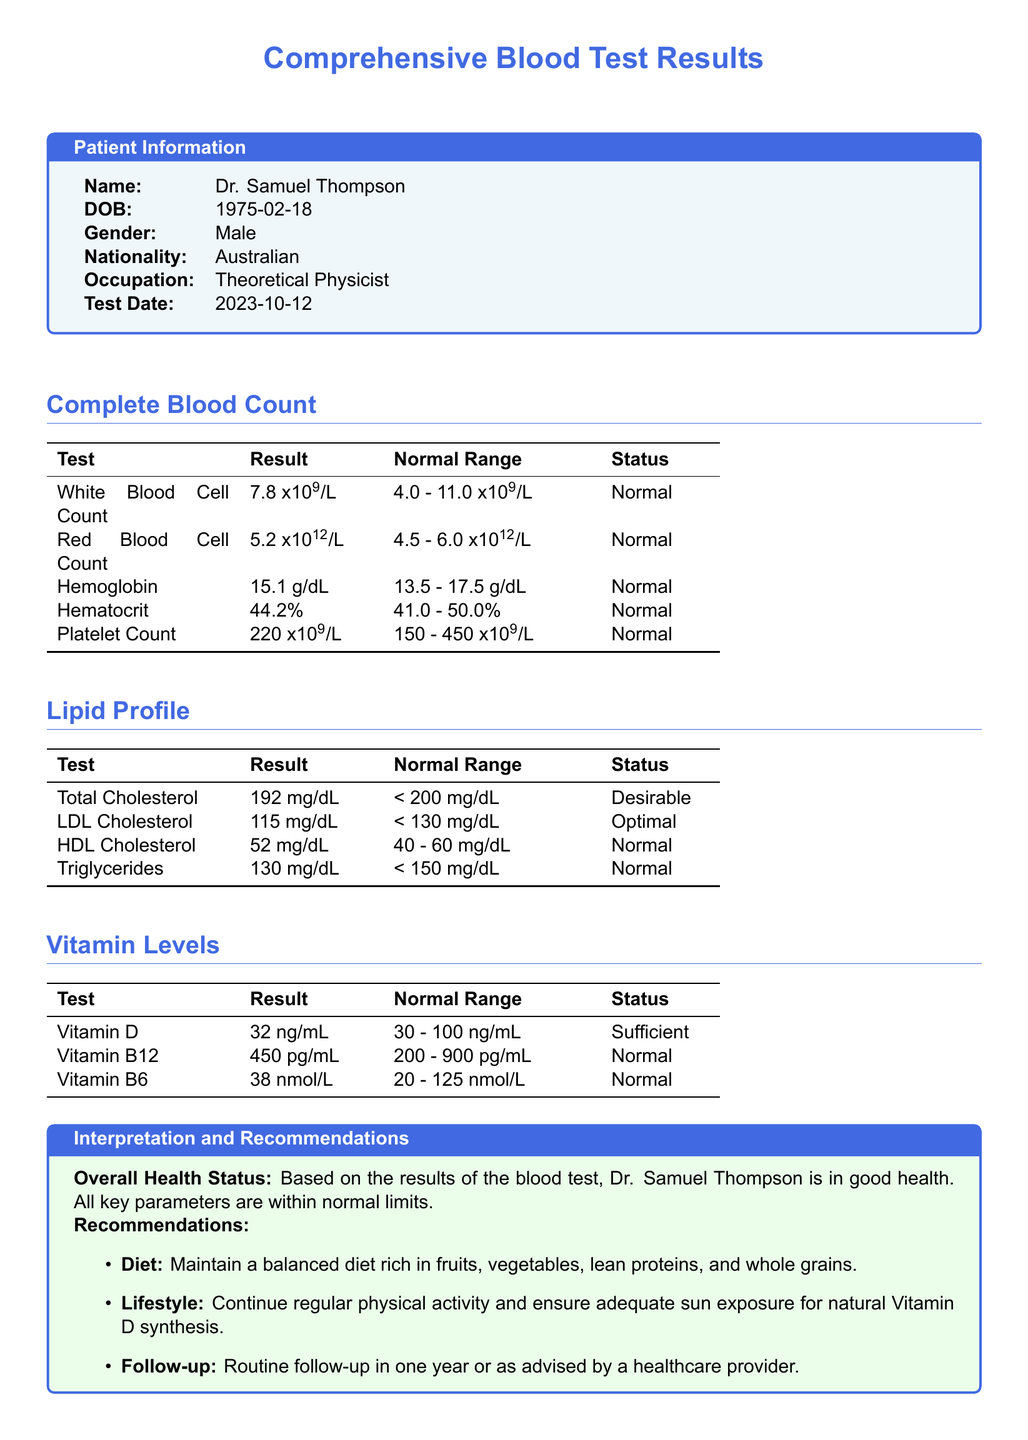What is the patient's name? The patient's name is provided in the Patient Information section of the document.
Answer: Dr. Samuel Thompson What is the date of the blood test? The test date is listed under Patient Information, indicating when the blood test was conducted.
Answer: 2023-10-12 What is the result of the White Blood Cell Count? This result is found in the Complete Blood Count section of the document.
Answer: 7.8 x10^9/L What is the normal range for HDL Cholesterol? The normal range for HDL Cholesterol is specified in the Lipid Profile section.
Answer: 40 - 60 mg/dL Which vitamin level is cited as 'Sufficient'? The Vitamin Levels section indicates specific vitamin levels and their statuses.
Answer: Vitamin D What is the interpretation of the overall health status? The overall health status is summarized in the Interpretation and Recommendations section of the document.
Answer: Good health What should be included in the lifestyle recommendations? Recommendations for lifestyle are detailed in the Interpretation and Recommendations section, outlining the patient's health maintenance strategy.
Answer: Regular physical activity What is the age of the patient? The patient's date of birth is provided; therefore, calculating the age as of the test date gives the answer.
Answer: 48 years old What is the result of Vitamin B12? The specific result for Vitamin B12 appears in the Vitamin Levels section.
Answer: 450 pg/mL 